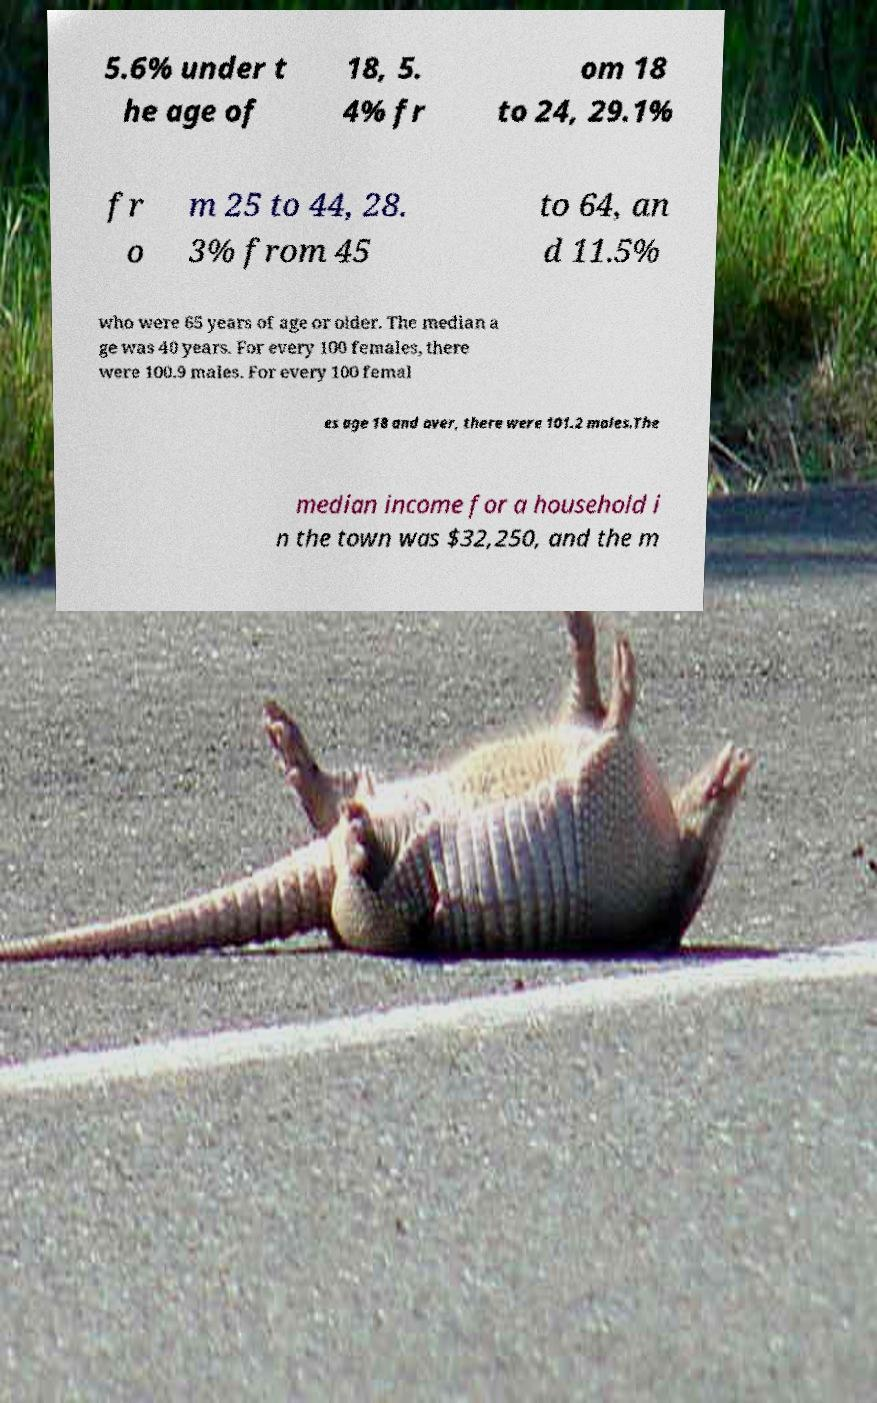I need the written content from this picture converted into text. Can you do that? 5.6% under t he age of 18, 5. 4% fr om 18 to 24, 29.1% fr o m 25 to 44, 28. 3% from 45 to 64, an d 11.5% who were 65 years of age or older. The median a ge was 40 years. For every 100 females, there were 100.9 males. For every 100 femal es age 18 and over, there were 101.2 males.The median income for a household i n the town was $32,250, and the m 